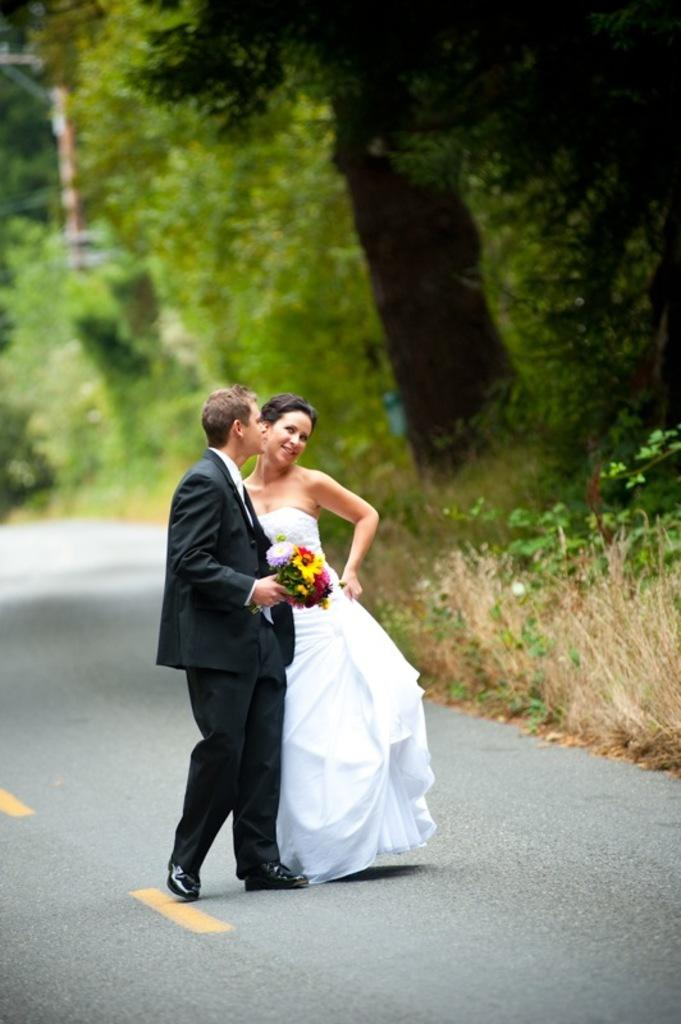Who are the main subjects in the image? There is a man and a lady in the center of the image. What is the man holding in his hand? The man is holding flowers in his hand. What can be seen in the background of the image? There are trees in the background of the image. What is at the bottom of the image? There is a road at the bottom of the image. Can you see any fear in the man's expression as he approaches the quicksand in the image? There is no quicksand present in the image, and the man's expression cannot be determined from the image. 